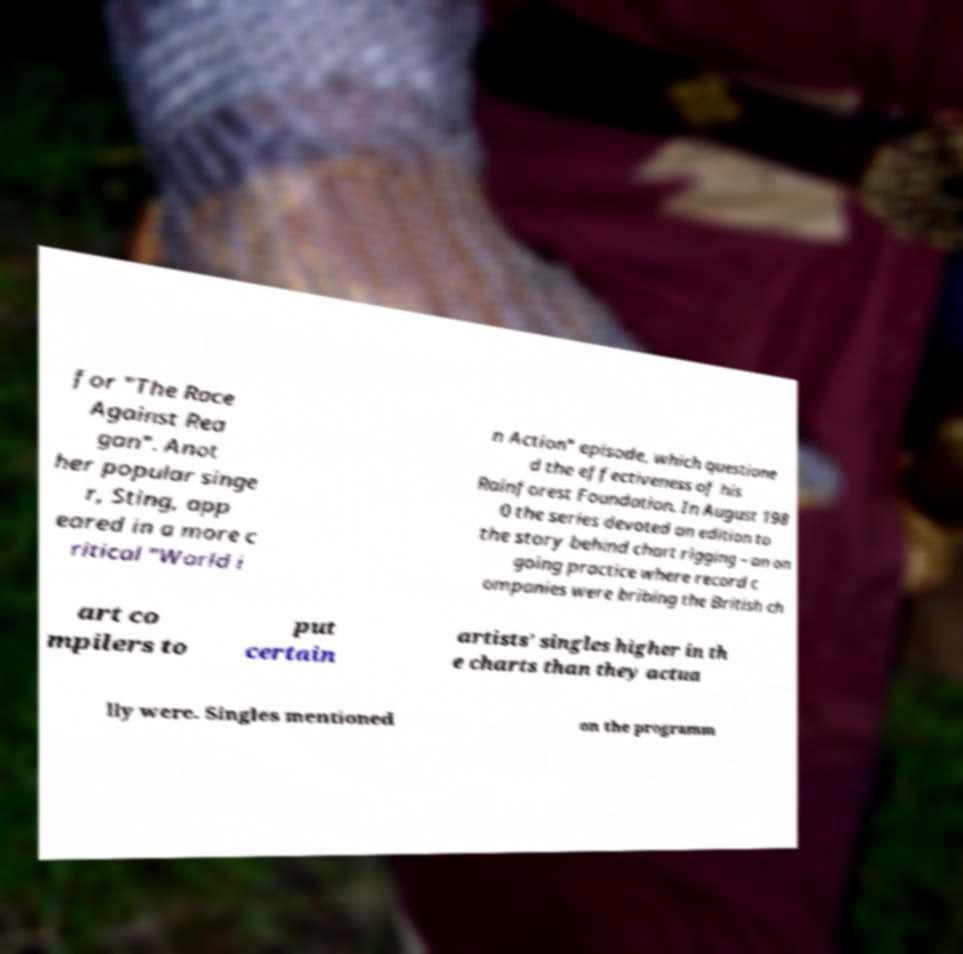I need the written content from this picture converted into text. Can you do that? for "The Race Against Rea gan". Anot her popular singe r, Sting, app eared in a more c ritical "World i n Action" episode, which questione d the effectiveness of his Rainforest Foundation. In August 198 0 the series devoted an edition to the story behind chart rigging – an on going practice where record c ompanies were bribing the British ch art co mpilers to put certain artists' singles higher in th e charts than they actua lly were. Singles mentioned on the programm 